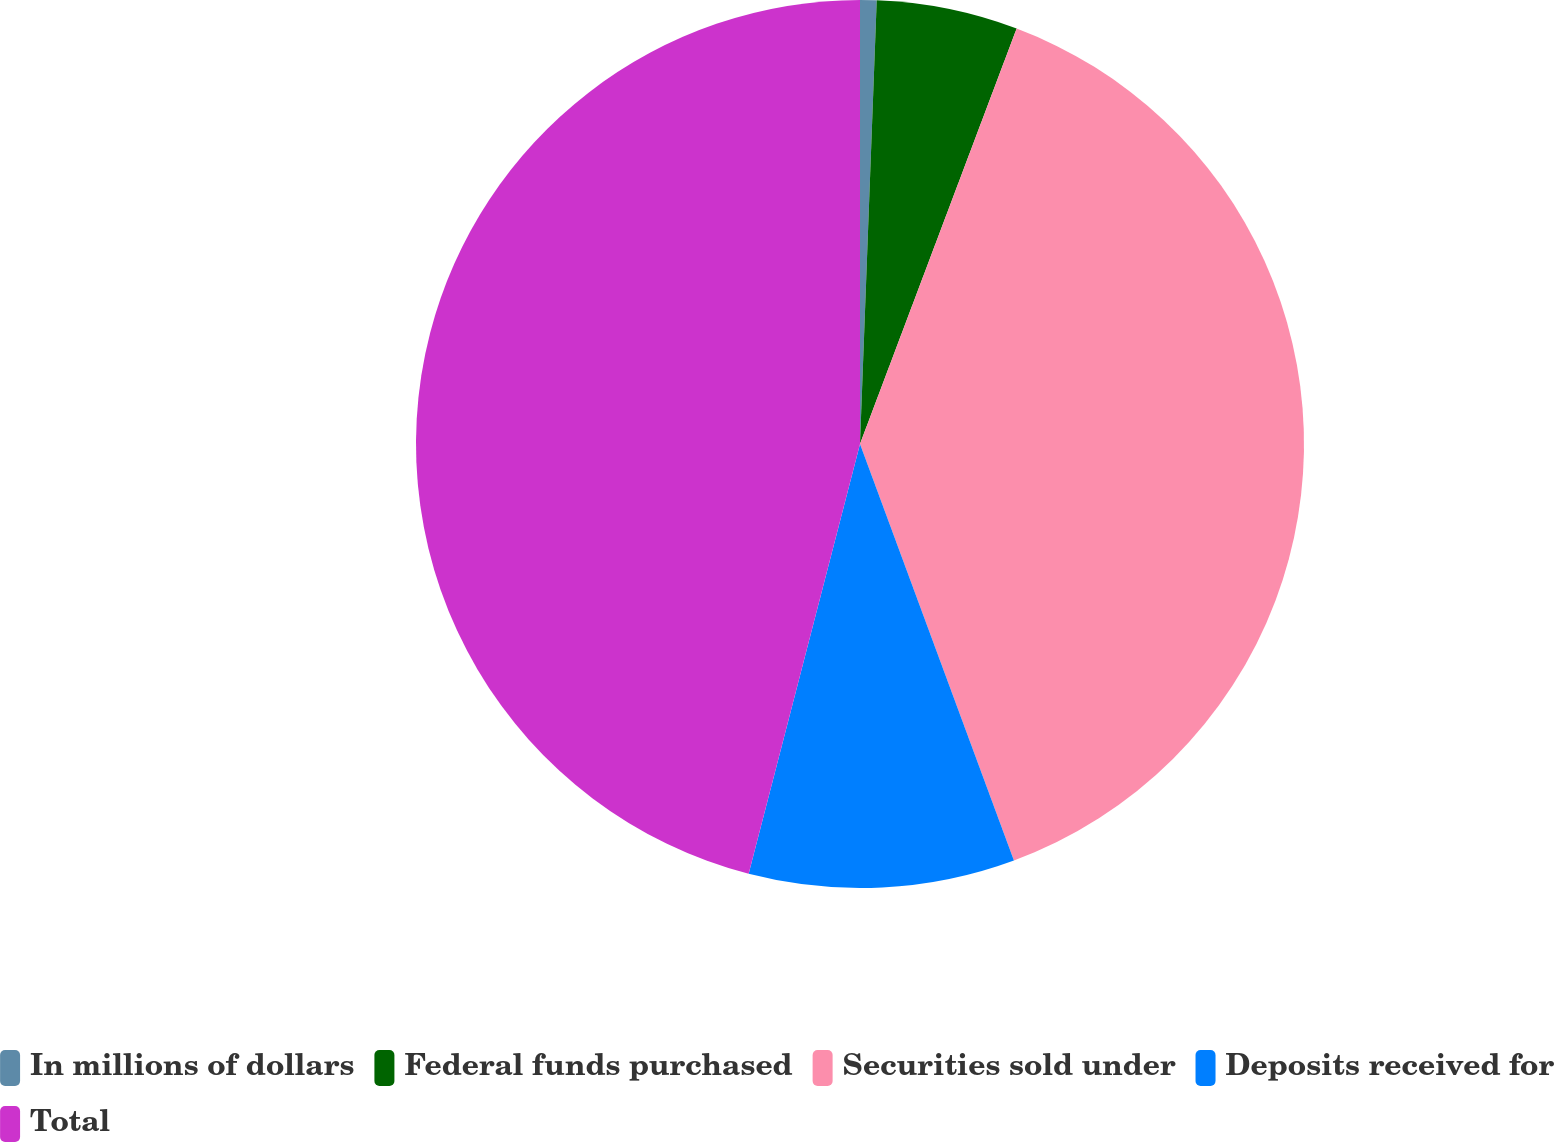Convert chart. <chart><loc_0><loc_0><loc_500><loc_500><pie_chart><fcel>In millions of dollars<fcel>Federal funds purchased<fcel>Securities sold under<fcel>Deposits received for<fcel>Total<nl><fcel>0.6%<fcel>5.14%<fcel>38.63%<fcel>9.67%<fcel>45.97%<nl></chart> 